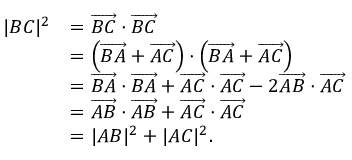Convert formula to latex. <formula><loc_0><loc_0><loc_500><loc_500>{ \begin{array} { r l } { | B C | ^ { 2 } } & { = { \overrightarrow { B C } } \cdot { \overrightarrow { B C } } } \\ & { = \left ( { \overrightarrow { B A } } + { \overrightarrow { A C } } \right ) \cdot \left ( { \overrightarrow { B A } } + { \overrightarrow { A C } } \right ) } \\ & { = { \overrightarrow { B A } } \cdot { \overrightarrow { B A } } + { \overrightarrow { A C } } \cdot { \overrightarrow { A C } } - 2 { \overrightarrow { A B } } \cdot { \overrightarrow { A C } } } \\ & { = { \overrightarrow { A B } } \cdot { \overrightarrow { A B } } + { \overrightarrow { A C } } \cdot { \overrightarrow { A C } } } \\ & { = | A B | ^ { 2 } + | A C | ^ { 2 } . } \end{array} }</formula> 